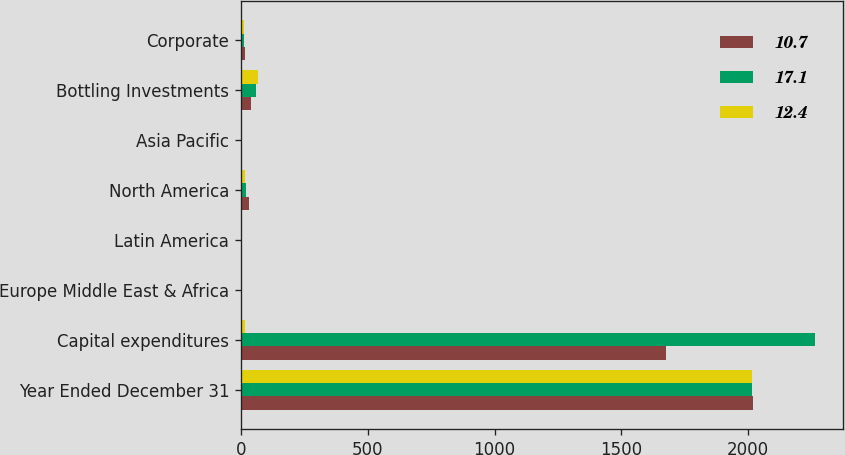Convert chart to OTSL. <chart><loc_0><loc_0><loc_500><loc_500><stacked_bar_chart><ecel><fcel>Year Ended December 31<fcel>Capital expenditures<fcel>Europe Middle East & Africa<fcel>Latin America<fcel>North America<fcel>Asia Pacific<fcel>Bottling Investments<fcel>Corporate<nl><fcel>10.7<fcel>2017<fcel>1675<fcel>4.8<fcel>3.3<fcel>32.3<fcel>3<fcel>39.5<fcel>17.1<nl><fcel>17.1<fcel>2016<fcel>2262<fcel>2.7<fcel>2<fcel>19.4<fcel>4.7<fcel>58.8<fcel>12.4<nl><fcel>12.4<fcel>2015<fcel>14.8<fcel>2.1<fcel>2.7<fcel>14.8<fcel>3.2<fcel>66.5<fcel>10.7<nl></chart> 